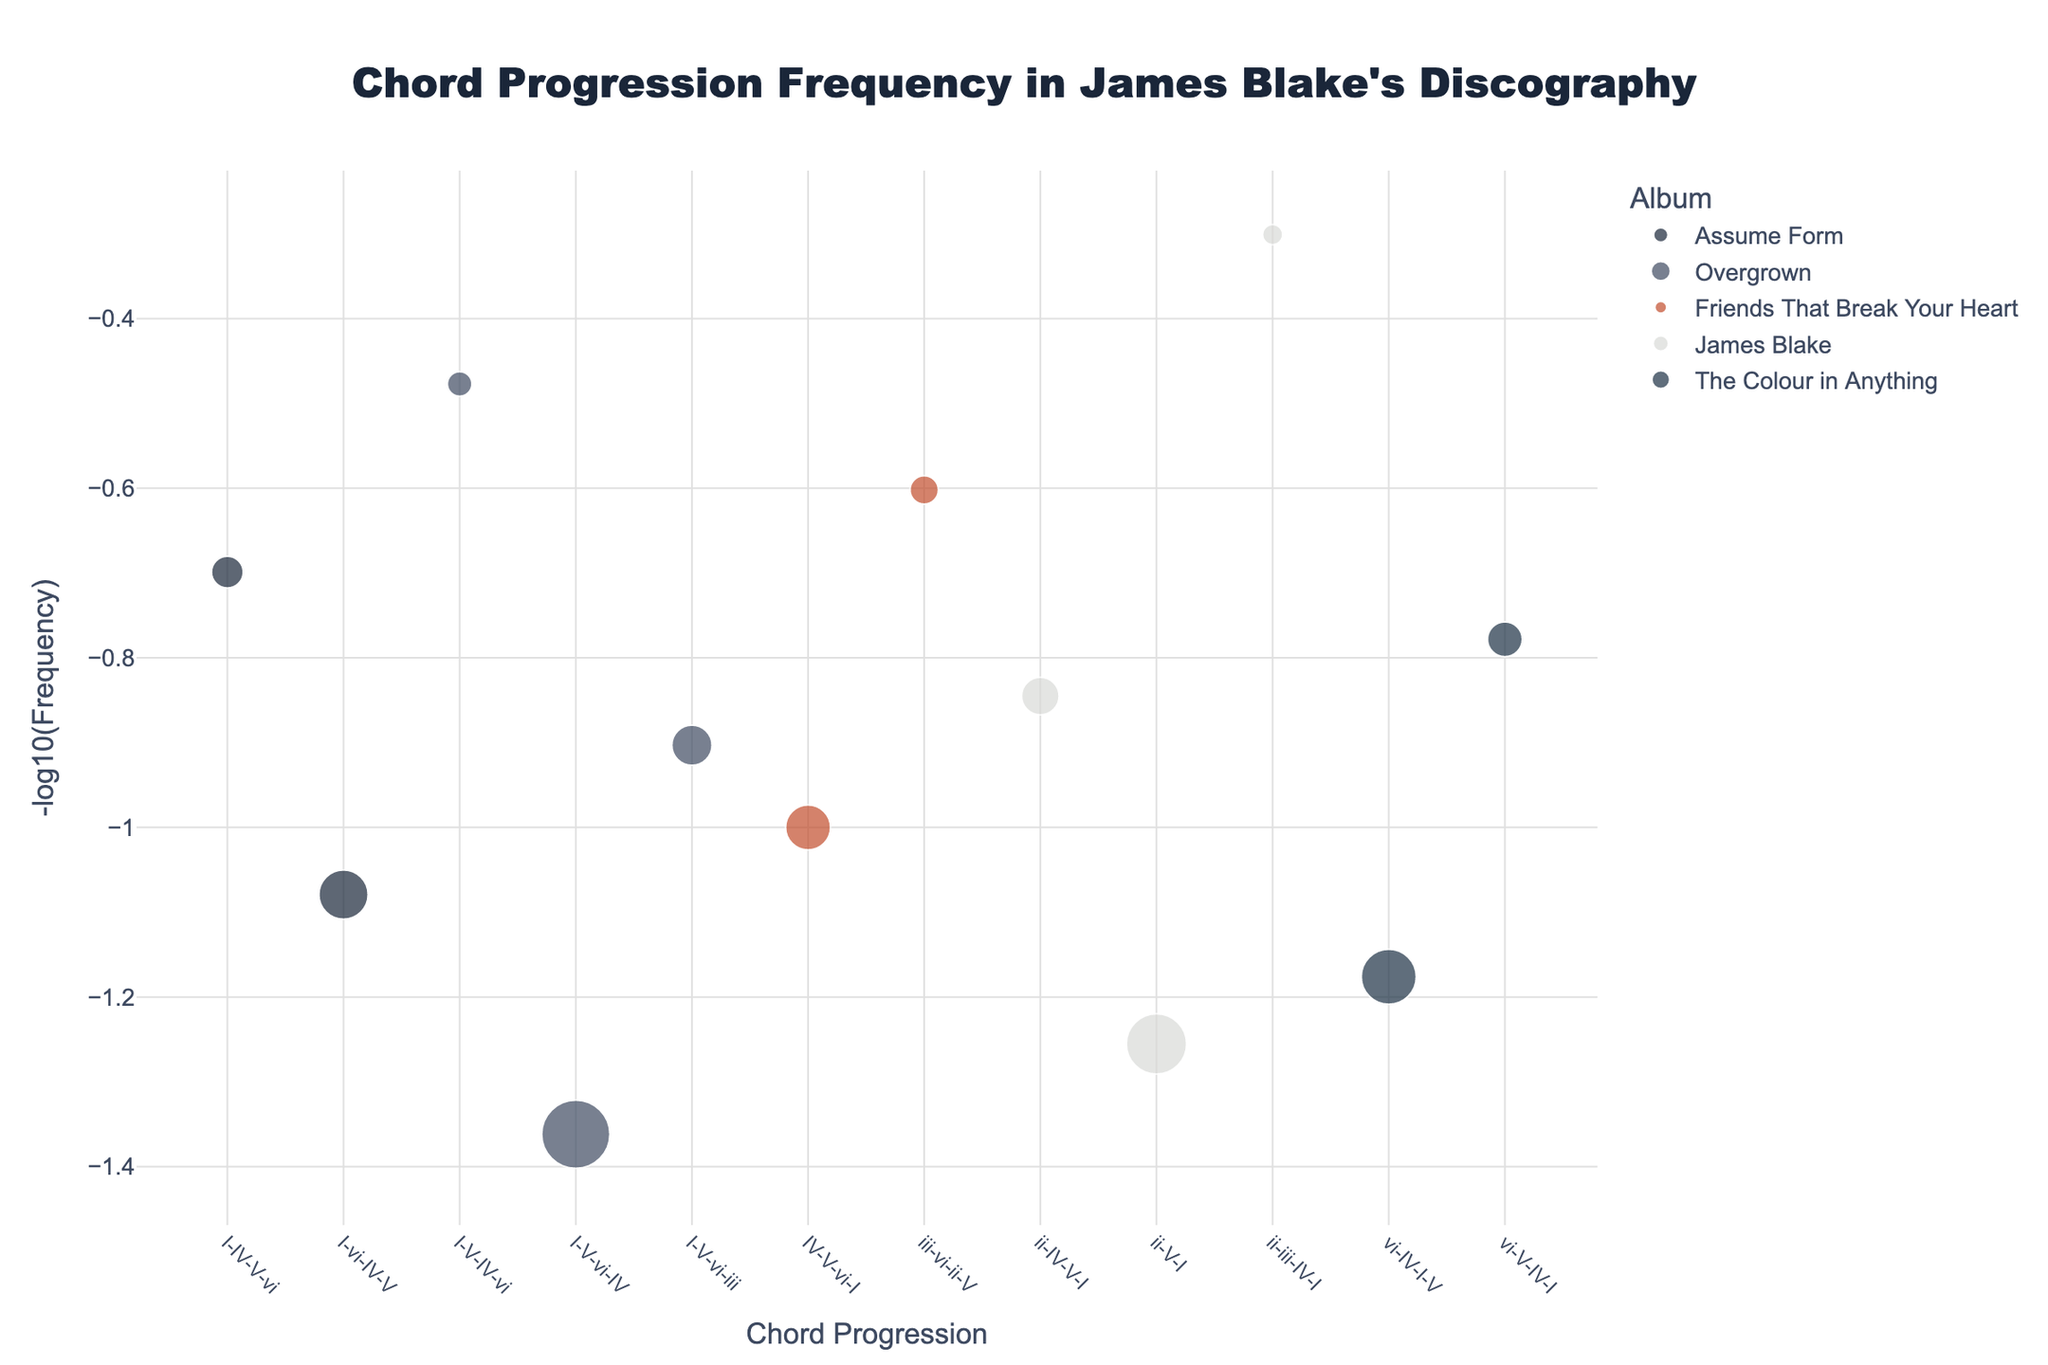How frequently does the chord progression I-V-vi-IV appear on the album "Overgrown"? The chord I-V-vi-IV, marked by larger point sizes, appears more frequently in "Overgrown". According to the data, it appears 23 times.
Answer: 23 Which chord progression has the lowest frequency and on which album is it found? The lowest frequency marked by the smallest point size corresponds to ii-iii-IV-I with a frequency of 2, found on the album "James Blake".
Answer: 2, James Blake What is the median of the negative log frequencies for chord progressions in "The Colour in Anything"? First, we need to list the negative log frequencies for "The Colour in Anything": -log10(15), -log10(6) ≈ 1.18, 0.78. The median of these values, sorted in ascending order (0.78, 1.18) is 0.98.
Answer: ~0.98 How many chord progressions from the album "Assume Form" appear in the plot? By counting the unique points for the album "Assume Form" as indicated in the legend and their corresponding points on the x-axis, we have two chord progressions.
Answer: 2 Which album has the most diverse range of chord frequencies based on the plot? "Overgrown" shows the greatest diversity with chord frequencies from 23 (I-V-vi-IV) to 3 (I-V-IV-vi). The range from high to low frequencies is more extensive compared to other albums.
Answer: Overgrown Between the chord progressions I-vi-IV-V and ii-V-I, which has a higher negative log frequency and why? To compare, -log10 for I-vi-IV-V is -log10(12) ≈ 1.08 and ii-V-I is -log10(18) ≈ 1.25. Therefore, ii-V-I has a higher negative log frequency.
Answer: ii-V-I Which chord progression has the unique largest marker size in "James Blake"? Observing marker sizes for "James Blake", the largest corresponds to ii-V-I with a frequency marker size of 18, making it the largest for that album.
Answer: ii-V-I What trend can be seen regarding the most frequent chord progressions and their appearance across different albums? The trend shows that "Overgrown" has the highest range of chord progression frequencies used with some high-frequency progressions like I-V-vi-IV. This diverse range is less seen in other albums, which exhibit more consistent and lower frequencies.
Answer: Overgrown high frequency trend What conclusions can be drawn about the chord progressions in James Blake's album "Friends That Break Your Heart"? From the plot, "Friends That Break Your Heart" shows that its chord progressions, like IV-V-vi-I and iii-vi-ii-V, have relatively lower frequencies (10 and 4), suggesting a more experimental or varied use of chord progressions.
Answer: Varied, lower frequencies 